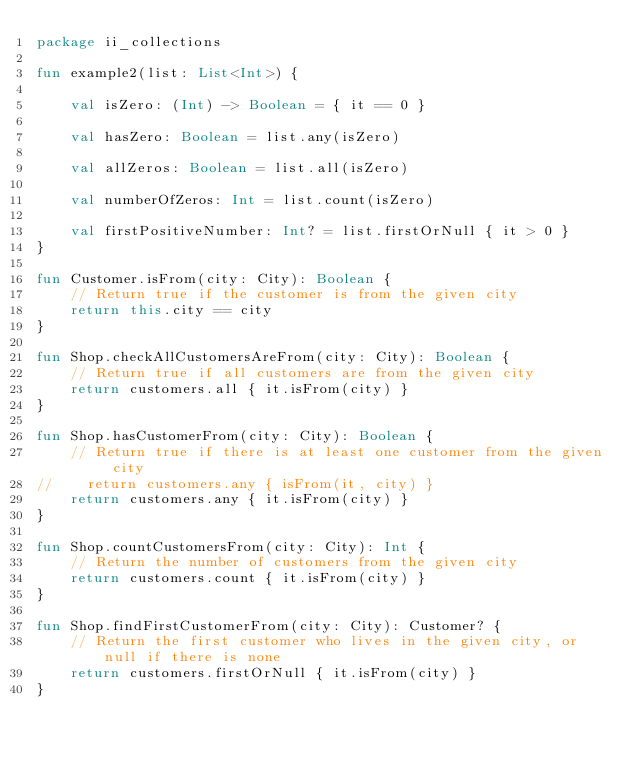Convert code to text. <code><loc_0><loc_0><loc_500><loc_500><_Kotlin_>package ii_collections

fun example2(list: List<Int>) {

    val isZero: (Int) -> Boolean = { it == 0 }

    val hasZero: Boolean = list.any(isZero)

    val allZeros: Boolean = list.all(isZero)

    val numberOfZeros: Int = list.count(isZero)

    val firstPositiveNumber: Int? = list.firstOrNull { it > 0 }
}

fun Customer.isFrom(city: City): Boolean {
    // Return true if the customer is from the given city
    return this.city == city
}

fun Shop.checkAllCustomersAreFrom(city: City): Boolean {
    // Return true if all customers are from the given city
    return customers.all { it.isFrom(city) }
}

fun Shop.hasCustomerFrom(city: City): Boolean {
    // Return true if there is at least one customer from the given city
//    return customers.any { isFrom(it, city) }
    return customers.any { it.isFrom(city) }
}

fun Shop.countCustomersFrom(city: City): Int {
    // Return the number of customers from the given city
    return customers.count { it.isFrom(city) }
}

fun Shop.findFirstCustomerFrom(city: City): Customer? {
    // Return the first customer who lives in the given city, or null if there is none
    return customers.firstOrNull { it.isFrom(city) }
}
</code> 